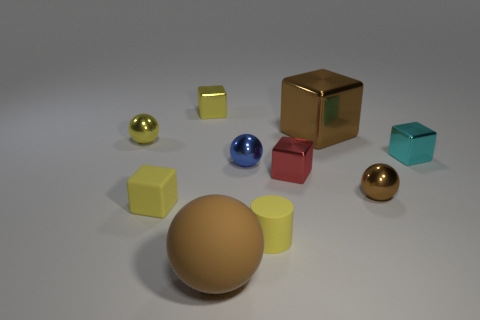What shape is the blue shiny object that is the same size as the cyan metal cube?
Provide a succinct answer. Sphere. There is a tiny cylinder; are there any yellow things left of it?
Make the answer very short. Yes. Is the brown shiny block the same size as the brown matte thing?
Offer a very short reply. Yes. There is a large brown object behind the yellow cylinder; what is its shape?
Your answer should be very brief. Cube. Is there a gray metallic ball of the same size as the yellow cylinder?
Ensure brevity in your answer.  No. There is a blue sphere that is the same size as the red thing; what is it made of?
Offer a terse response. Metal. There is a matte sphere in front of the tiny cyan metallic thing; what size is it?
Offer a very short reply. Large. The blue metallic object has what size?
Provide a short and direct response. Small. Is the size of the yellow cylinder the same as the yellow block that is behind the cyan thing?
Your answer should be compact. Yes. The object that is in front of the rubber cylinder that is in front of the small cyan block is what color?
Provide a succinct answer. Brown. 